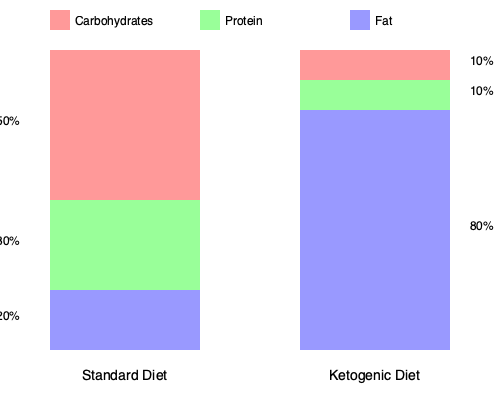Based on the stacked bar chart comparing the macronutrient composition of a standard diet and a ketogenic diet, what is the percentage difference in fat content between the two diets? To find the percentage difference in fat content between the standard diet and the ketogenic diet, we need to follow these steps:

1. Identify the fat content in each diet:
   - Standard diet: 20% fat
   - Ketogenic diet: 80% fat

2. Calculate the difference in fat content:
   $80\% - 20\% = 60\%$

3. Express this difference as a percentage of the standard diet's fat content:
   $\frac{\text{Difference}}{\text{Standard diet fat content}} \times 100\%$
   
   $\frac{60\%}{20\%} \times 100\% = 3 \times 100\% = 300\%$

Therefore, the percentage difference in fat content between the ketogenic diet and the standard diet is 300%.
Answer: 300% 